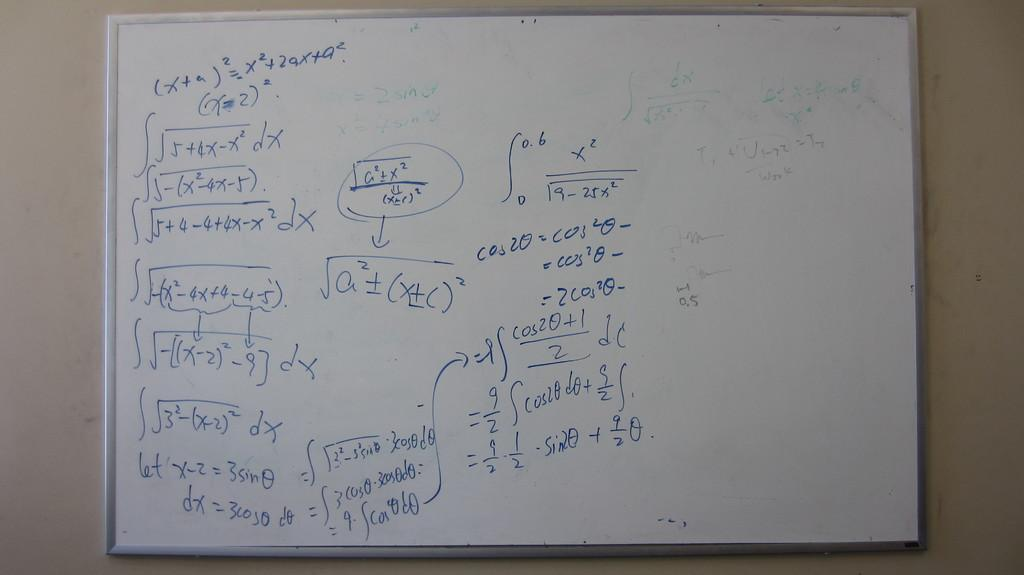<image>
Offer a succinct explanation of the picture presented. White board that have equations and arrows with math 